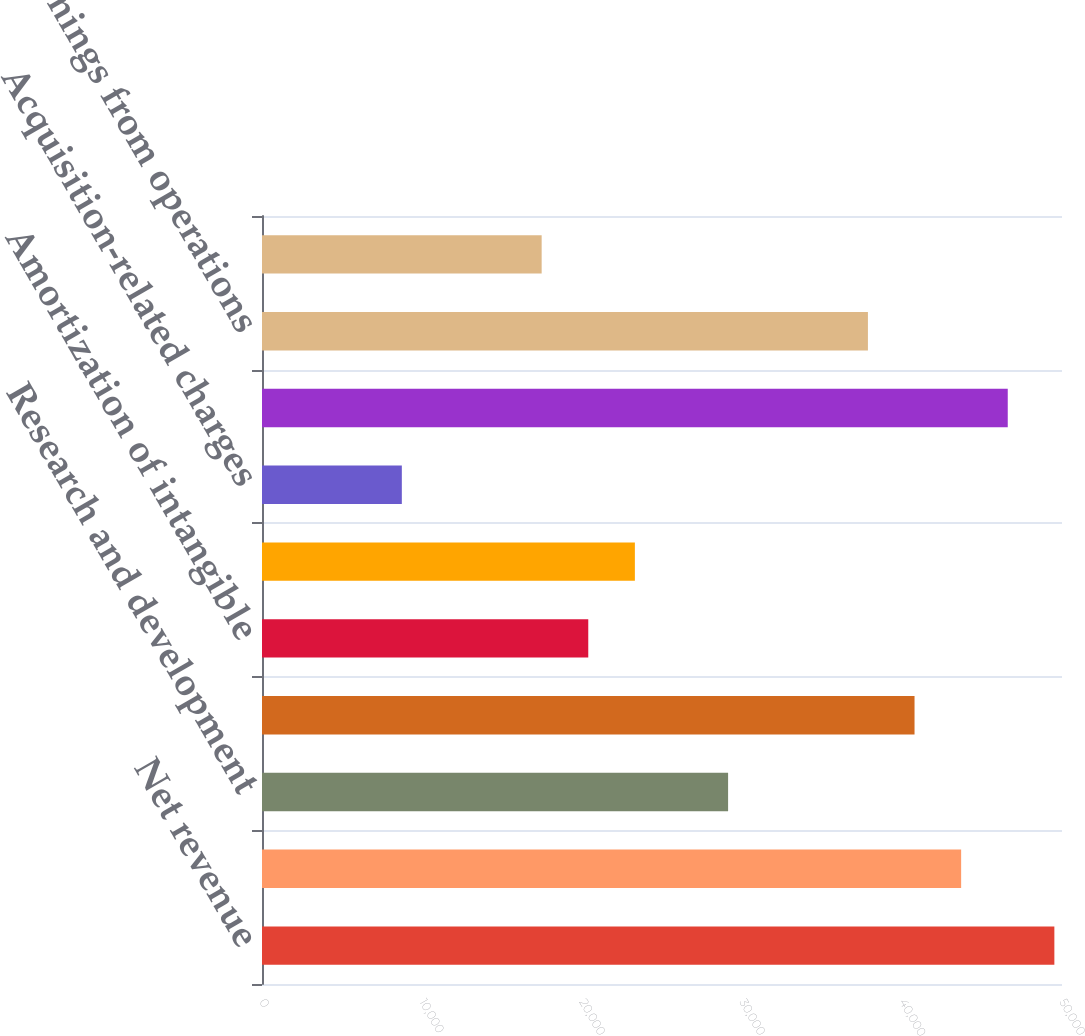Convert chart. <chart><loc_0><loc_0><loc_500><loc_500><bar_chart><fcel>Net revenue<fcel>Cost of sales (1)<fcel>Research and development<fcel>Selling general and<fcel>Amortization of intangible<fcel>Restructuring charges<fcel>Acquisition-related charges<fcel>Total costs and expenses<fcel>Earnings from operations<fcel>Interest and other net<nl><fcel>49522.6<fcel>43696.4<fcel>29131<fcel>40783.3<fcel>20391.8<fcel>23304.8<fcel>8739.4<fcel>46609.5<fcel>37870.2<fcel>17478.7<nl></chart> 